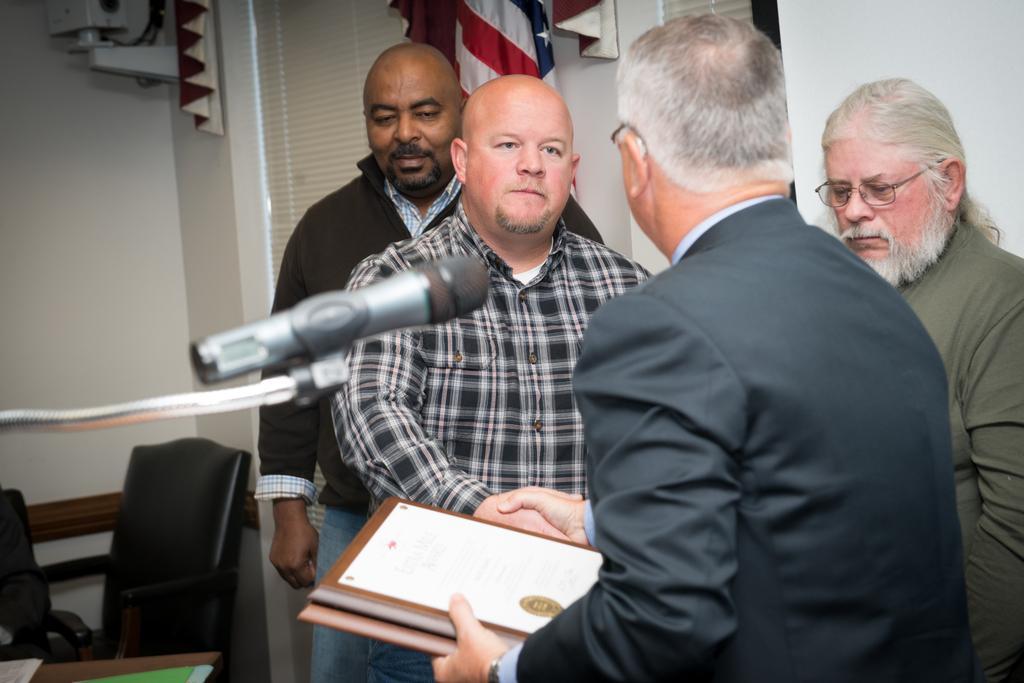Can you describe this image briefly? There are many people standing. In the front person is holding some books. Also there is a mic and mic stand in the front. In the background there is a chair, table, wall, curtain and a flag. 